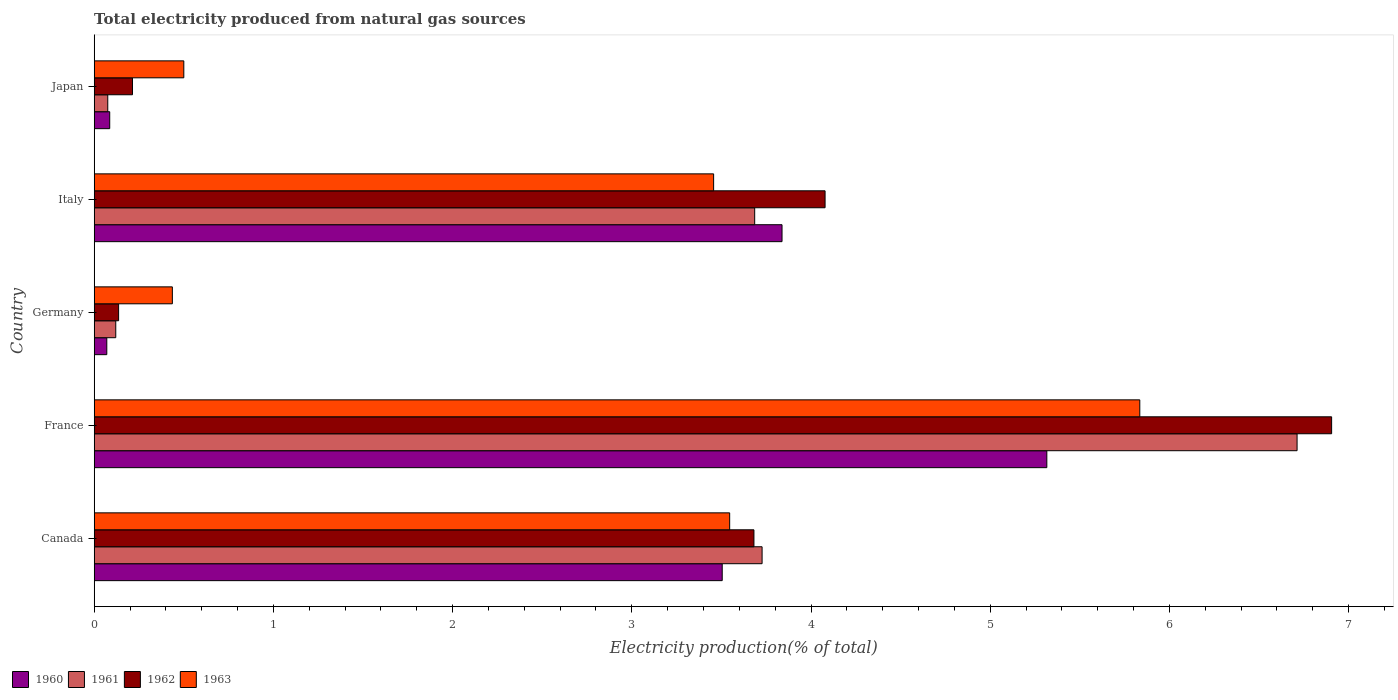How many different coloured bars are there?
Offer a terse response. 4. How many groups of bars are there?
Provide a succinct answer. 5. Are the number of bars per tick equal to the number of legend labels?
Make the answer very short. Yes. Are the number of bars on each tick of the Y-axis equal?
Offer a very short reply. Yes. How many bars are there on the 5th tick from the top?
Your answer should be very brief. 4. What is the label of the 2nd group of bars from the top?
Offer a very short reply. Italy. In how many cases, is the number of bars for a given country not equal to the number of legend labels?
Make the answer very short. 0. What is the total electricity produced in 1961 in Germany?
Ensure brevity in your answer.  0.12. Across all countries, what is the maximum total electricity produced in 1961?
Keep it short and to the point. 6.71. Across all countries, what is the minimum total electricity produced in 1963?
Give a very brief answer. 0.44. What is the total total electricity produced in 1960 in the graph?
Your response must be concise. 12.82. What is the difference between the total electricity produced in 1961 in Canada and that in Italy?
Ensure brevity in your answer.  0.04. What is the difference between the total electricity produced in 1961 in Japan and the total electricity produced in 1962 in France?
Your response must be concise. -6.83. What is the average total electricity produced in 1963 per country?
Provide a short and direct response. 2.75. What is the difference between the total electricity produced in 1963 and total electricity produced in 1962 in Italy?
Keep it short and to the point. -0.62. What is the ratio of the total electricity produced in 1960 in Canada to that in France?
Provide a succinct answer. 0.66. What is the difference between the highest and the second highest total electricity produced in 1963?
Provide a short and direct response. 2.29. What is the difference between the highest and the lowest total electricity produced in 1962?
Your answer should be very brief. 6.77. Is the sum of the total electricity produced in 1960 in France and Italy greater than the maximum total electricity produced in 1961 across all countries?
Your response must be concise. Yes. What does the 2nd bar from the top in Italy represents?
Keep it short and to the point. 1962. Are all the bars in the graph horizontal?
Give a very brief answer. Yes. How many countries are there in the graph?
Offer a terse response. 5. Does the graph contain any zero values?
Your answer should be compact. No. Does the graph contain grids?
Your answer should be very brief. No. Where does the legend appear in the graph?
Your answer should be very brief. Bottom left. What is the title of the graph?
Your response must be concise. Total electricity produced from natural gas sources. What is the label or title of the Y-axis?
Provide a short and direct response. Country. What is the Electricity production(% of total) in 1960 in Canada?
Provide a short and direct response. 3.5. What is the Electricity production(% of total) of 1961 in Canada?
Ensure brevity in your answer.  3.73. What is the Electricity production(% of total) in 1962 in Canada?
Keep it short and to the point. 3.68. What is the Electricity production(% of total) of 1963 in Canada?
Keep it short and to the point. 3.55. What is the Electricity production(% of total) in 1960 in France?
Provide a short and direct response. 5.32. What is the Electricity production(% of total) of 1961 in France?
Your answer should be compact. 6.71. What is the Electricity production(% of total) of 1962 in France?
Your answer should be very brief. 6.91. What is the Electricity production(% of total) of 1963 in France?
Your answer should be compact. 5.83. What is the Electricity production(% of total) in 1960 in Germany?
Offer a very short reply. 0.07. What is the Electricity production(% of total) of 1961 in Germany?
Provide a succinct answer. 0.12. What is the Electricity production(% of total) in 1962 in Germany?
Offer a terse response. 0.14. What is the Electricity production(% of total) in 1963 in Germany?
Offer a terse response. 0.44. What is the Electricity production(% of total) in 1960 in Italy?
Your answer should be very brief. 3.84. What is the Electricity production(% of total) in 1961 in Italy?
Ensure brevity in your answer.  3.69. What is the Electricity production(% of total) in 1962 in Italy?
Provide a short and direct response. 4.08. What is the Electricity production(% of total) in 1963 in Italy?
Provide a short and direct response. 3.46. What is the Electricity production(% of total) in 1960 in Japan?
Ensure brevity in your answer.  0.09. What is the Electricity production(% of total) in 1961 in Japan?
Keep it short and to the point. 0.08. What is the Electricity production(% of total) of 1962 in Japan?
Give a very brief answer. 0.21. What is the Electricity production(% of total) in 1963 in Japan?
Offer a very short reply. 0.5. Across all countries, what is the maximum Electricity production(% of total) of 1960?
Offer a terse response. 5.32. Across all countries, what is the maximum Electricity production(% of total) of 1961?
Give a very brief answer. 6.71. Across all countries, what is the maximum Electricity production(% of total) in 1962?
Your answer should be compact. 6.91. Across all countries, what is the maximum Electricity production(% of total) in 1963?
Your answer should be compact. 5.83. Across all countries, what is the minimum Electricity production(% of total) in 1960?
Your response must be concise. 0.07. Across all countries, what is the minimum Electricity production(% of total) of 1961?
Provide a short and direct response. 0.08. Across all countries, what is the minimum Electricity production(% of total) of 1962?
Offer a terse response. 0.14. Across all countries, what is the minimum Electricity production(% of total) of 1963?
Keep it short and to the point. 0.44. What is the total Electricity production(% of total) of 1960 in the graph?
Offer a very short reply. 12.82. What is the total Electricity production(% of total) of 1961 in the graph?
Provide a short and direct response. 14.32. What is the total Electricity production(% of total) of 1962 in the graph?
Your response must be concise. 15.01. What is the total Electricity production(% of total) of 1963 in the graph?
Your answer should be very brief. 13.77. What is the difference between the Electricity production(% of total) in 1960 in Canada and that in France?
Your answer should be very brief. -1.81. What is the difference between the Electricity production(% of total) of 1961 in Canada and that in France?
Your answer should be very brief. -2.99. What is the difference between the Electricity production(% of total) in 1962 in Canada and that in France?
Your response must be concise. -3.22. What is the difference between the Electricity production(% of total) in 1963 in Canada and that in France?
Provide a short and direct response. -2.29. What is the difference between the Electricity production(% of total) of 1960 in Canada and that in Germany?
Your response must be concise. 3.43. What is the difference between the Electricity production(% of total) in 1961 in Canada and that in Germany?
Offer a terse response. 3.61. What is the difference between the Electricity production(% of total) in 1962 in Canada and that in Germany?
Provide a succinct answer. 3.55. What is the difference between the Electricity production(% of total) in 1963 in Canada and that in Germany?
Provide a succinct answer. 3.11. What is the difference between the Electricity production(% of total) of 1960 in Canada and that in Italy?
Your answer should be compact. -0.33. What is the difference between the Electricity production(% of total) of 1961 in Canada and that in Italy?
Your response must be concise. 0.04. What is the difference between the Electricity production(% of total) of 1962 in Canada and that in Italy?
Give a very brief answer. -0.4. What is the difference between the Electricity production(% of total) in 1963 in Canada and that in Italy?
Keep it short and to the point. 0.09. What is the difference between the Electricity production(% of total) of 1960 in Canada and that in Japan?
Make the answer very short. 3.42. What is the difference between the Electricity production(% of total) of 1961 in Canada and that in Japan?
Make the answer very short. 3.65. What is the difference between the Electricity production(% of total) of 1962 in Canada and that in Japan?
Ensure brevity in your answer.  3.47. What is the difference between the Electricity production(% of total) of 1963 in Canada and that in Japan?
Your response must be concise. 3.05. What is the difference between the Electricity production(% of total) of 1960 in France and that in Germany?
Give a very brief answer. 5.25. What is the difference between the Electricity production(% of total) of 1961 in France and that in Germany?
Ensure brevity in your answer.  6.59. What is the difference between the Electricity production(% of total) of 1962 in France and that in Germany?
Offer a very short reply. 6.77. What is the difference between the Electricity production(% of total) of 1963 in France and that in Germany?
Ensure brevity in your answer.  5.4. What is the difference between the Electricity production(% of total) of 1960 in France and that in Italy?
Offer a terse response. 1.48. What is the difference between the Electricity production(% of total) of 1961 in France and that in Italy?
Your answer should be very brief. 3.03. What is the difference between the Electricity production(% of total) of 1962 in France and that in Italy?
Ensure brevity in your answer.  2.83. What is the difference between the Electricity production(% of total) of 1963 in France and that in Italy?
Your answer should be very brief. 2.38. What is the difference between the Electricity production(% of total) of 1960 in France and that in Japan?
Provide a succinct answer. 5.23. What is the difference between the Electricity production(% of total) of 1961 in France and that in Japan?
Offer a terse response. 6.64. What is the difference between the Electricity production(% of total) of 1962 in France and that in Japan?
Your response must be concise. 6.69. What is the difference between the Electricity production(% of total) in 1963 in France and that in Japan?
Offer a terse response. 5.33. What is the difference between the Electricity production(% of total) in 1960 in Germany and that in Italy?
Your response must be concise. -3.77. What is the difference between the Electricity production(% of total) in 1961 in Germany and that in Italy?
Provide a short and direct response. -3.57. What is the difference between the Electricity production(% of total) in 1962 in Germany and that in Italy?
Provide a short and direct response. -3.94. What is the difference between the Electricity production(% of total) of 1963 in Germany and that in Italy?
Keep it short and to the point. -3.02. What is the difference between the Electricity production(% of total) of 1960 in Germany and that in Japan?
Offer a very short reply. -0.02. What is the difference between the Electricity production(% of total) of 1961 in Germany and that in Japan?
Your answer should be compact. 0.04. What is the difference between the Electricity production(% of total) of 1962 in Germany and that in Japan?
Offer a terse response. -0.08. What is the difference between the Electricity production(% of total) in 1963 in Germany and that in Japan?
Offer a terse response. -0.06. What is the difference between the Electricity production(% of total) in 1960 in Italy and that in Japan?
Your answer should be compact. 3.75. What is the difference between the Electricity production(% of total) in 1961 in Italy and that in Japan?
Offer a very short reply. 3.61. What is the difference between the Electricity production(% of total) in 1962 in Italy and that in Japan?
Keep it short and to the point. 3.86. What is the difference between the Electricity production(% of total) of 1963 in Italy and that in Japan?
Your answer should be very brief. 2.96. What is the difference between the Electricity production(% of total) in 1960 in Canada and the Electricity production(% of total) in 1961 in France?
Ensure brevity in your answer.  -3.21. What is the difference between the Electricity production(% of total) in 1960 in Canada and the Electricity production(% of total) in 1962 in France?
Ensure brevity in your answer.  -3.4. What is the difference between the Electricity production(% of total) in 1960 in Canada and the Electricity production(% of total) in 1963 in France?
Give a very brief answer. -2.33. What is the difference between the Electricity production(% of total) of 1961 in Canada and the Electricity production(% of total) of 1962 in France?
Make the answer very short. -3.18. What is the difference between the Electricity production(% of total) in 1961 in Canada and the Electricity production(% of total) in 1963 in France?
Make the answer very short. -2.11. What is the difference between the Electricity production(% of total) in 1962 in Canada and the Electricity production(% of total) in 1963 in France?
Provide a short and direct response. -2.15. What is the difference between the Electricity production(% of total) of 1960 in Canada and the Electricity production(% of total) of 1961 in Germany?
Give a very brief answer. 3.38. What is the difference between the Electricity production(% of total) of 1960 in Canada and the Electricity production(% of total) of 1962 in Germany?
Ensure brevity in your answer.  3.37. What is the difference between the Electricity production(% of total) in 1960 in Canada and the Electricity production(% of total) in 1963 in Germany?
Give a very brief answer. 3.07. What is the difference between the Electricity production(% of total) of 1961 in Canada and the Electricity production(% of total) of 1962 in Germany?
Ensure brevity in your answer.  3.59. What is the difference between the Electricity production(% of total) in 1961 in Canada and the Electricity production(% of total) in 1963 in Germany?
Make the answer very short. 3.29. What is the difference between the Electricity production(% of total) of 1962 in Canada and the Electricity production(% of total) of 1963 in Germany?
Make the answer very short. 3.25. What is the difference between the Electricity production(% of total) in 1960 in Canada and the Electricity production(% of total) in 1961 in Italy?
Your response must be concise. -0.18. What is the difference between the Electricity production(% of total) in 1960 in Canada and the Electricity production(% of total) in 1962 in Italy?
Offer a terse response. -0.57. What is the difference between the Electricity production(% of total) of 1960 in Canada and the Electricity production(% of total) of 1963 in Italy?
Your response must be concise. 0.05. What is the difference between the Electricity production(% of total) in 1961 in Canada and the Electricity production(% of total) in 1962 in Italy?
Your response must be concise. -0.35. What is the difference between the Electricity production(% of total) in 1961 in Canada and the Electricity production(% of total) in 1963 in Italy?
Ensure brevity in your answer.  0.27. What is the difference between the Electricity production(% of total) in 1962 in Canada and the Electricity production(% of total) in 1963 in Italy?
Your answer should be very brief. 0.23. What is the difference between the Electricity production(% of total) of 1960 in Canada and the Electricity production(% of total) of 1961 in Japan?
Provide a succinct answer. 3.43. What is the difference between the Electricity production(% of total) of 1960 in Canada and the Electricity production(% of total) of 1962 in Japan?
Give a very brief answer. 3.29. What is the difference between the Electricity production(% of total) of 1960 in Canada and the Electricity production(% of total) of 1963 in Japan?
Give a very brief answer. 3. What is the difference between the Electricity production(% of total) of 1961 in Canada and the Electricity production(% of total) of 1962 in Japan?
Ensure brevity in your answer.  3.51. What is the difference between the Electricity production(% of total) in 1961 in Canada and the Electricity production(% of total) in 1963 in Japan?
Offer a terse response. 3.23. What is the difference between the Electricity production(% of total) of 1962 in Canada and the Electricity production(% of total) of 1963 in Japan?
Make the answer very short. 3.18. What is the difference between the Electricity production(% of total) of 1960 in France and the Electricity production(% of total) of 1961 in Germany?
Your answer should be very brief. 5.2. What is the difference between the Electricity production(% of total) in 1960 in France and the Electricity production(% of total) in 1962 in Germany?
Offer a terse response. 5.18. What is the difference between the Electricity production(% of total) of 1960 in France and the Electricity production(% of total) of 1963 in Germany?
Offer a terse response. 4.88. What is the difference between the Electricity production(% of total) in 1961 in France and the Electricity production(% of total) in 1962 in Germany?
Make the answer very short. 6.58. What is the difference between the Electricity production(% of total) of 1961 in France and the Electricity production(% of total) of 1963 in Germany?
Your answer should be very brief. 6.28. What is the difference between the Electricity production(% of total) of 1962 in France and the Electricity production(% of total) of 1963 in Germany?
Provide a short and direct response. 6.47. What is the difference between the Electricity production(% of total) of 1960 in France and the Electricity production(% of total) of 1961 in Italy?
Provide a succinct answer. 1.63. What is the difference between the Electricity production(% of total) of 1960 in France and the Electricity production(% of total) of 1962 in Italy?
Provide a succinct answer. 1.24. What is the difference between the Electricity production(% of total) of 1960 in France and the Electricity production(% of total) of 1963 in Italy?
Provide a short and direct response. 1.86. What is the difference between the Electricity production(% of total) in 1961 in France and the Electricity production(% of total) in 1962 in Italy?
Your response must be concise. 2.63. What is the difference between the Electricity production(% of total) of 1961 in France and the Electricity production(% of total) of 1963 in Italy?
Offer a very short reply. 3.26. What is the difference between the Electricity production(% of total) of 1962 in France and the Electricity production(% of total) of 1963 in Italy?
Give a very brief answer. 3.45. What is the difference between the Electricity production(% of total) in 1960 in France and the Electricity production(% of total) in 1961 in Japan?
Offer a very short reply. 5.24. What is the difference between the Electricity production(% of total) in 1960 in France and the Electricity production(% of total) in 1962 in Japan?
Your answer should be very brief. 5.1. What is the difference between the Electricity production(% of total) of 1960 in France and the Electricity production(% of total) of 1963 in Japan?
Give a very brief answer. 4.82. What is the difference between the Electricity production(% of total) in 1961 in France and the Electricity production(% of total) in 1962 in Japan?
Give a very brief answer. 6.5. What is the difference between the Electricity production(% of total) in 1961 in France and the Electricity production(% of total) in 1963 in Japan?
Offer a terse response. 6.21. What is the difference between the Electricity production(% of total) in 1962 in France and the Electricity production(% of total) in 1963 in Japan?
Make the answer very short. 6.4. What is the difference between the Electricity production(% of total) of 1960 in Germany and the Electricity production(% of total) of 1961 in Italy?
Provide a short and direct response. -3.62. What is the difference between the Electricity production(% of total) in 1960 in Germany and the Electricity production(% of total) in 1962 in Italy?
Your answer should be compact. -4.01. What is the difference between the Electricity production(% of total) in 1960 in Germany and the Electricity production(% of total) in 1963 in Italy?
Offer a very short reply. -3.39. What is the difference between the Electricity production(% of total) in 1961 in Germany and the Electricity production(% of total) in 1962 in Italy?
Your answer should be very brief. -3.96. What is the difference between the Electricity production(% of total) of 1961 in Germany and the Electricity production(% of total) of 1963 in Italy?
Keep it short and to the point. -3.34. What is the difference between the Electricity production(% of total) in 1962 in Germany and the Electricity production(% of total) in 1963 in Italy?
Make the answer very short. -3.32. What is the difference between the Electricity production(% of total) of 1960 in Germany and the Electricity production(% of total) of 1961 in Japan?
Offer a very short reply. -0.01. What is the difference between the Electricity production(% of total) in 1960 in Germany and the Electricity production(% of total) in 1962 in Japan?
Keep it short and to the point. -0.14. What is the difference between the Electricity production(% of total) of 1960 in Germany and the Electricity production(% of total) of 1963 in Japan?
Ensure brevity in your answer.  -0.43. What is the difference between the Electricity production(% of total) of 1961 in Germany and the Electricity production(% of total) of 1962 in Japan?
Ensure brevity in your answer.  -0.09. What is the difference between the Electricity production(% of total) in 1961 in Germany and the Electricity production(% of total) in 1963 in Japan?
Your response must be concise. -0.38. What is the difference between the Electricity production(% of total) of 1962 in Germany and the Electricity production(% of total) of 1963 in Japan?
Make the answer very short. -0.36. What is the difference between the Electricity production(% of total) of 1960 in Italy and the Electricity production(% of total) of 1961 in Japan?
Your response must be concise. 3.76. What is the difference between the Electricity production(% of total) in 1960 in Italy and the Electricity production(% of total) in 1962 in Japan?
Give a very brief answer. 3.62. What is the difference between the Electricity production(% of total) of 1960 in Italy and the Electricity production(% of total) of 1963 in Japan?
Offer a very short reply. 3.34. What is the difference between the Electricity production(% of total) in 1961 in Italy and the Electricity production(% of total) in 1962 in Japan?
Give a very brief answer. 3.47. What is the difference between the Electricity production(% of total) in 1961 in Italy and the Electricity production(% of total) in 1963 in Japan?
Make the answer very short. 3.19. What is the difference between the Electricity production(% of total) in 1962 in Italy and the Electricity production(% of total) in 1963 in Japan?
Offer a terse response. 3.58. What is the average Electricity production(% of total) of 1960 per country?
Offer a terse response. 2.56. What is the average Electricity production(% of total) in 1961 per country?
Keep it short and to the point. 2.86. What is the average Electricity production(% of total) of 1962 per country?
Give a very brief answer. 3. What is the average Electricity production(% of total) of 1963 per country?
Give a very brief answer. 2.75. What is the difference between the Electricity production(% of total) of 1960 and Electricity production(% of total) of 1961 in Canada?
Your answer should be compact. -0.22. What is the difference between the Electricity production(% of total) of 1960 and Electricity production(% of total) of 1962 in Canada?
Offer a very short reply. -0.18. What is the difference between the Electricity production(% of total) of 1960 and Electricity production(% of total) of 1963 in Canada?
Your answer should be very brief. -0.04. What is the difference between the Electricity production(% of total) in 1961 and Electricity production(% of total) in 1962 in Canada?
Your response must be concise. 0.05. What is the difference between the Electricity production(% of total) of 1961 and Electricity production(% of total) of 1963 in Canada?
Ensure brevity in your answer.  0.18. What is the difference between the Electricity production(% of total) in 1962 and Electricity production(% of total) in 1963 in Canada?
Make the answer very short. 0.14. What is the difference between the Electricity production(% of total) of 1960 and Electricity production(% of total) of 1961 in France?
Give a very brief answer. -1.4. What is the difference between the Electricity production(% of total) of 1960 and Electricity production(% of total) of 1962 in France?
Ensure brevity in your answer.  -1.59. What is the difference between the Electricity production(% of total) in 1960 and Electricity production(% of total) in 1963 in France?
Offer a very short reply. -0.52. What is the difference between the Electricity production(% of total) of 1961 and Electricity production(% of total) of 1962 in France?
Your response must be concise. -0.19. What is the difference between the Electricity production(% of total) in 1961 and Electricity production(% of total) in 1963 in France?
Ensure brevity in your answer.  0.88. What is the difference between the Electricity production(% of total) in 1962 and Electricity production(% of total) in 1963 in France?
Keep it short and to the point. 1.07. What is the difference between the Electricity production(% of total) in 1960 and Electricity production(% of total) in 1962 in Germany?
Make the answer very short. -0.07. What is the difference between the Electricity production(% of total) of 1960 and Electricity production(% of total) of 1963 in Germany?
Provide a succinct answer. -0.37. What is the difference between the Electricity production(% of total) of 1961 and Electricity production(% of total) of 1962 in Germany?
Your answer should be compact. -0.02. What is the difference between the Electricity production(% of total) of 1961 and Electricity production(% of total) of 1963 in Germany?
Your answer should be compact. -0.32. What is the difference between the Electricity production(% of total) of 1962 and Electricity production(% of total) of 1963 in Germany?
Your response must be concise. -0.3. What is the difference between the Electricity production(% of total) of 1960 and Electricity production(% of total) of 1961 in Italy?
Give a very brief answer. 0.15. What is the difference between the Electricity production(% of total) in 1960 and Electricity production(% of total) in 1962 in Italy?
Give a very brief answer. -0.24. What is the difference between the Electricity production(% of total) of 1960 and Electricity production(% of total) of 1963 in Italy?
Keep it short and to the point. 0.38. What is the difference between the Electricity production(% of total) of 1961 and Electricity production(% of total) of 1962 in Italy?
Offer a terse response. -0.39. What is the difference between the Electricity production(% of total) of 1961 and Electricity production(% of total) of 1963 in Italy?
Make the answer very short. 0.23. What is the difference between the Electricity production(% of total) of 1962 and Electricity production(% of total) of 1963 in Italy?
Your answer should be compact. 0.62. What is the difference between the Electricity production(% of total) of 1960 and Electricity production(% of total) of 1961 in Japan?
Keep it short and to the point. 0.01. What is the difference between the Electricity production(% of total) of 1960 and Electricity production(% of total) of 1962 in Japan?
Provide a succinct answer. -0.13. What is the difference between the Electricity production(% of total) of 1960 and Electricity production(% of total) of 1963 in Japan?
Provide a short and direct response. -0.41. What is the difference between the Electricity production(% of total) in 1961 and Electricity production(% of total) in 1962 in Japan?
Ensure brevity in your answer.  -0.14. What is the difference between the Electricity production(% of total) in 1961 and Electricity production(% of total) in 1963 in Japan?
Keep it short and to the point. -0.42. What is the difference between the Electricity production(% of total) in 1962 and Electricity production(% of total) in 1963 in Japan?
Make the answer very short. -0.29. What is the ratio of the Electricity production(% of total) of 1960 in Canada to that in France?
Give a very brief answer. 0.66. What is the ratio of the Electricity production(% of total) in 1961 in Canada to that in France?
Your answer should be very brief. 0.56. What is the ratio of the Electricity production(% of total) in 1962 in Canada to that in France?
Keep it short and to the point. 0.53. What is the ratio of the Electricity production(% of total) of 1963 in Canada to that in France?
Keep it short and to the point. 0.61. What is the ratio of the Electricity production(% of total) in 1960 in Canada to that in Germany?
Offer a very short reply. 49.85. What is the ratio of the Electricity production(% of total) of 1961 in Canada to that in Germany?
Provide a short and direct response. 30.98. What is the ratio of the Electricity production(% of total) in 1962 in Canada to that in Germany?
Keep it short and to the point. 27.02. What is the ratio of the Electricity production(% of total) of 1963 in Canada to that in Germany?
Offer a very short reply. 8.13. What is the ratio of the Electricity production(% of total) in 1960 in Canada to that in Italy?
Your answer should be compact. 0.91. What is the ratio of the Electricity production(% of total) of 1961 in Canada to that in Italy?
Keep it short and to the point. 1.01. What is the ratio of the Electricity production(% of total) of 1962 in Canada to that in Italy?
Your response must be concise. 0.9. What is the ratio of the Electricity production(% of total) of 1963 in Canada to that in Italy?
Offer a terse response. 1.03. What is the ratio of the Electricity production(% of total) of 1960 in Canada to that in Japan?
Provide a short and direct response. 40.48. What is the ratio of the Electricity production(% of total) in 1961 in Canada to that in Japan?
Offer a very short reply. 49.23. What is the ratio of the Electricity production(% of total) of 1962 in Canada to that in Japan?
Your response must be concise. 17.23. What is the ratio of the Electricity production(% of total) of 1963 in Canada to that in Japan?
Give a very brief answer. 7.09. What is the ratio of the Electricity production(% of total) in 1960 in France to that in Germany?
Your answer should be compact. 75.62. What is the ratio of the Electricity production(% of total) in 1961 in France to that in Germany?
Your answer should be very brief. 55.79. What is the ratio of the Electricity production(% of total) of 1962 in France to that in Germany?
Provide a succinct answer. 50.69. What is the ratio of the Electricity production(% of total) in 1963 in France to that in Germany?
Offer a very short reply. 13.38. What is the ratio of the Electricity production(% of total) in 1960 in France to that in Italy?
Keep it short and to the point. 1.39. What is the ratio of the Electricity production(% of total) in 1961 in France to that in Italy?
Your answer should be very brief. 1.82. What is the ratio of the Electricity production(% of total) of 1962 in France to that in Italy?
Your response must be concise. 1.69. What is the ratio of the Electricity production(% of total) of 1963 in France to that in Italy?
Offer a very short reply. 1.69. What is the ratio of the Electricity production(% of total) of 1960 in France to that in Japan?
Keep it short and to the point. 61.4. What is the ratio of the Electricity production(% of total) in 1961 in France to that in Japan?
Offer a very short reply. 88.67. What is the ratio of the Electricity production(% of total) in 1962 in France to that in Japan?
Make the answer very short. 32.32. What is the ratio of the Electricity production(% of total) in 1963 in France to that in Japan?
Your answer should be very brief. 11.67. What is the ratio of the Electricity production(% of total) of 1960 in Germany to that in Italy?
Your answer should be very brief. 0.02. What is the ratio of the Electricity production(% of total) in 1961 in Germany to that in Italy?
Your response must be concise. 0.03. What is the ratio of the Electricity production(% of total) in 1962 in Germany to that in Italy?
Ensure brevity in your answer.  0.03. What is the ratio of the Electricity production(% of total) in 1963 in Germany to that in Italy?
Provide a succinct answer. 0.13. What is the ratio of the Electricity production(% of total) in 1960 in Germany to that in Japan?
Make the answer very short. 0.81. What is the ratio of the Electricity production(% of total) in 1961 in Germany to that in Japan?
Offer a very short reply. 1.59. What is the ratio of the Electricity production(% of total) of 1962 in Germany to that in Japan?
Offer a very short reply. 0.64. What is the ratio of the Electricity production(% of total) of 1963 in Germany to that in Japan?
Provide a short and direct response. 0.87. What is the ratio of the Electricity production(% of total) of 1960 in Italy to that in Japan?
Offer a very short reply. 44.33. What is the ratio of the Electricity production(% of total) of 1961 in Italy to that in Japan?
Offer a very short reply. 48.69. What is the ratio of the Electricity production(% of total) of 1962 in Italy to that in Japan?
Your answer should be compact. 19.09. What is the ratio of the Electricity production(% of total) of 1963 in Italy to that in Japan?
Your response must be concise. 6.91. What is the difference between the highest and the second highest Electricity production(% of total) in 1960?
Offer a very short reply. 1.48. What is the difference between the highest and the second highest Electricity production(% of total) in 1961?
Your response must be concise. 2.99. What is the difference between the highest and the second highest Electricity production(% of total) in 1962?
Keep it short and to the point. 2.83. What is the difference between the highest and the second highest Electricity production(% of total) of 1963?
Ensure brevity in your answer.  2.29. What is the difference between the highest and the lowest Electricity production(% of total) in 1960?
Keep it short and to the point. 5.25. What is the difference between the highest and the lowest Electricity production(% of total) of 1961?
Your answer should be compact. 6.64. What is the difference between the highest and the lowest Electricity production(% of total) of 1962?
Provide a succinct answer. 6.77. What is the difference between the highest and the lowest Electricity production(% of total) in 1963?
Your response must be concise. 5.4. 